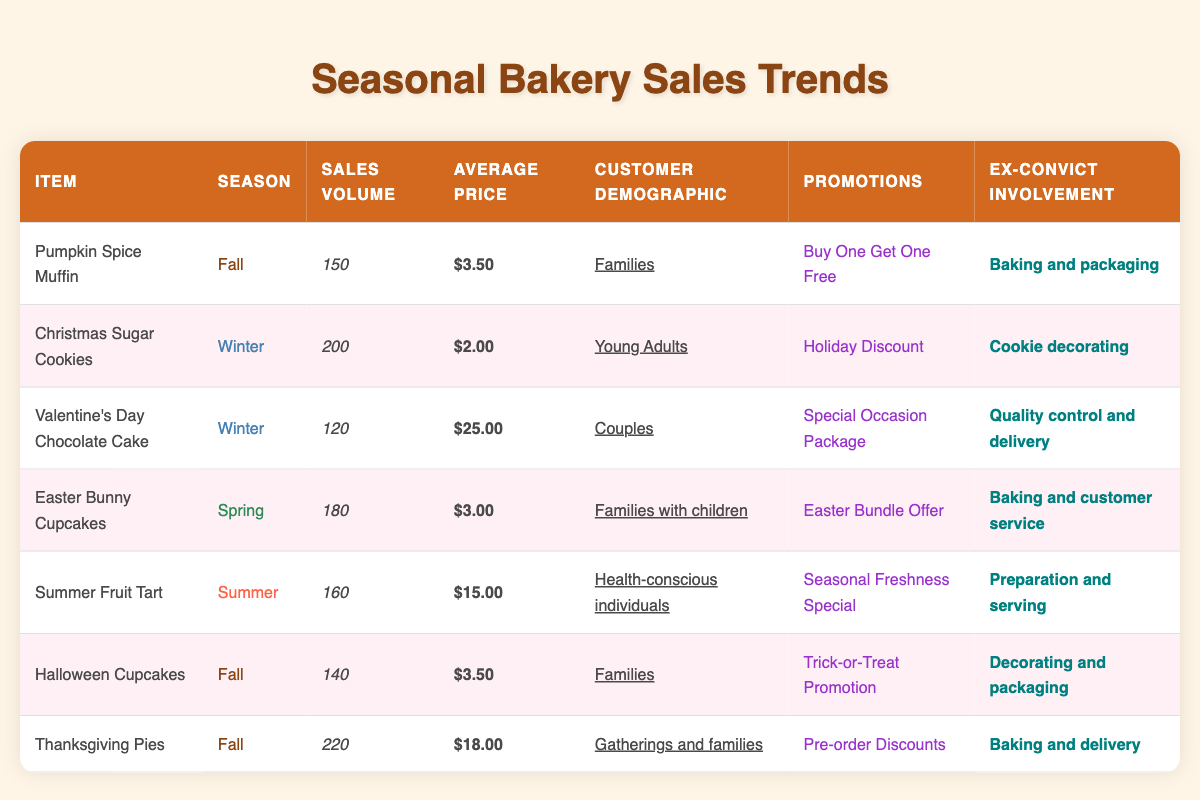What is the sales volume of Thanksgiving Pies? The sales volume of Thanksgiving Pies is listed directly in the table under the "Sales Volume" column for that item. The value is 220.
Answer: 220 How much do Easter Bunny Cupcakes cost on average? The average price for Easter Bunny Cupcakes can be found in the "Average Price" column next to the item name in the table. It is $3.00.
Answer: $3.00 Which seasonal item has the highest sales volume? To find the item with the highest sales volume, I will compare the values in the "Sales Volume" column. Thanksgiving Pies has the highest sales volume at 220.
Answer: Thanksgiving Pies Is it true that Summer Fruit Tart is aimed at health-conscious individuals? The customer demographic listed for Summer Fruit Tart is "Health-conscious individuals," which confirms this as true.
Answer: Yes What is the average price of seasonal items in the winter season? To find the average price of winter seasonal items, I need to sum up the average prices of Christmas Sugar Cookies ($2.00) and Valentine's Day Chocolate Cake ($25.00), which is $2.00 + $25.00 = $27.00. There are 2 items, so I divide by 2 to get the average: $27.00 / 2 = $13.50.
Answer: $13.50 How many seasonal items are targeted towards families? I will review the "Customer Demographic" column to identify which items are aimed at families. The items are Pumpkin Spice Muffin, Easter Bunny Cupcakes, and Halloween Cupcakes, making a total of 3 items.
Answer: 3 What special promotion is offered for Christmas Sugar Cookies? The promotion for Christmas Sugar Cookies is shown in the "Promotions" column corresponding to that item, which states "Holiday Discount."
Answer: Holiday Discount Which item involves ex-convicts in baking and delivery? Looking at the "Ex-Convict Involvement" column, Thanksgiving Pies involves ex-convicts in "Baking and delivery."
Answer: Thanksgiving Pies How many cupcakes are sold during Halloween? The sales volume for Halloween Cupcakes can be found directly in the table. The value is 140.
Answer: 140 